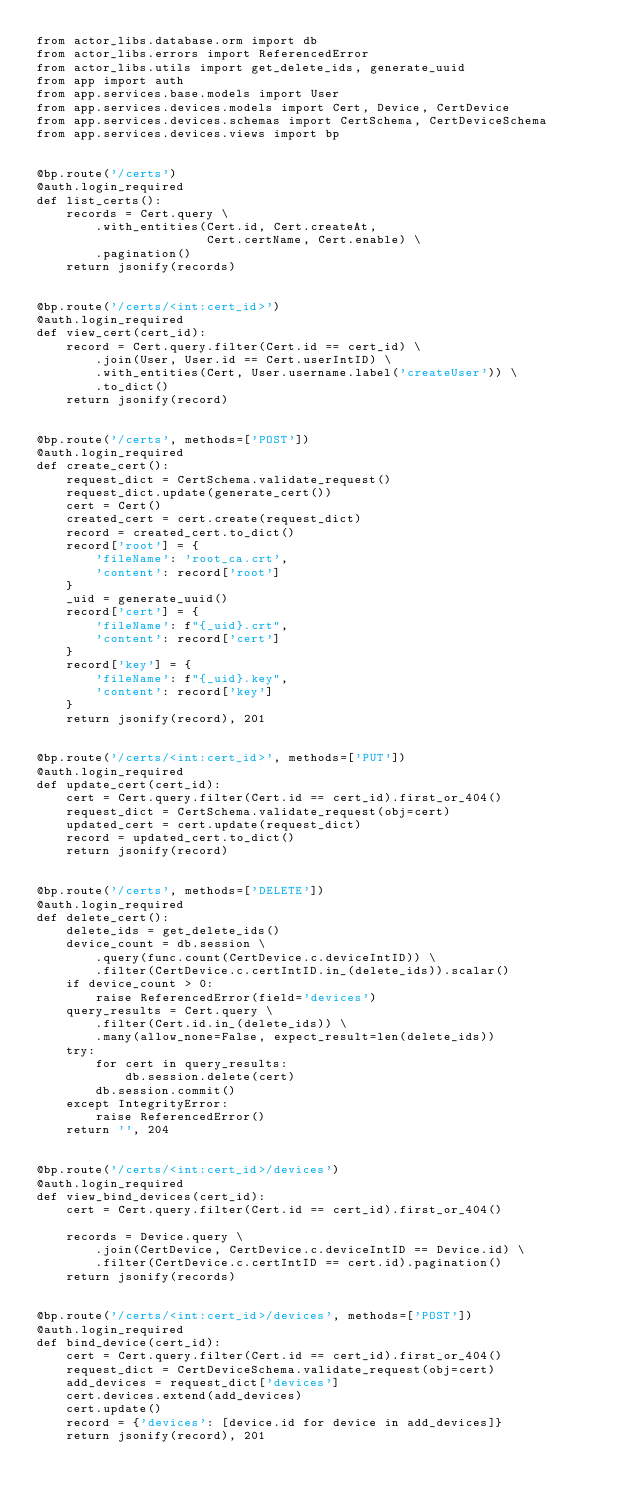Convert code to text. <code><loc_0><loc_0><loc_500><loc_500><_Python_>from actor_libs.database.orm import db
from actor_libs.errors import ReferencedError
from actor_libs.utils import get_delete_ids, generate_uuid
from app import auth
from app.services.base.models import User
from app.services.devices.models import Cert, Device, CertDevice
from app.services.devices.schemas import CertSchema, CertDeviceSchema
from app.services.devices.views import bp


@bp.route('/certs')
@auth.login_required
def list_certs():
    records = Cert.query \
        .with_entities(Cert.id, Cert.createAt,
                       Cert.certName, Cert.enable) \
        .pagination()
    return jsonify(records)


@bp.route('/certs/<int:cert_id>')
@auth.login_required
def view_cert(cert_id):
    record = Cert.query.filter(Cert.id == cert_id) \
        .join(User, User.id == Cert.userIntID) \
        .with_entities(Cert, User.username.label('createUser')) \
        .to_dict()
    return jsonify(record)


@bp.route('/certs', methods=['POST'])
@auth.login_required
def create_cert():
    request_dict = CertSchema.validate_request()
    request_dict.update(generate_cert())
    cert = Cert()
    created_cert = cert.create(request_dict)
    record = created_cert.to_dict()
    record['root'] = {
        'fileName': 'root_ca.crt',
        'content': record['root']
    }
    _uid = generate_uuid()
    record['cert'] = {
        'fileName': f"{_uid}.crt",
        'content': record['cert']
    }
    record['key'] = {
        'fileName': f"{_uid}.key",
        'content': record['key']
    }
    return jsonify(record), 201


@bp.route('/certs/<int:cert_id>', methods=['PUT'])
@auth.login_required
def update_cert(cert_id):
    cert = Cert.query.filter(Cert.id == cert_id).first_or_404()
    request_dict = CertSchema.validate_request(obj=cert)
    updated_cert = cert.update(request_dict)
    record = updated_cert.to_dict()
    return jsonify(record)


@bp.route('/certs', methods=['DELETE'])
@auth.login_required
def delete_cert():
    delete_ids = get_delete_ids()
    device_count = db.session \
        .query(func.count(CertDevice.c.deviceIntID)) \
        .filter(CertDevice.c.certIntID.in_(delete_ids)).scalar()
    if device_count > 0:
        raise ReferencedError(field='devices')
    query_results = Cert.query \
        .filter(Cert.id.in_(delete_ids)) \
        .many(allow_none=False, expect_result=len(delete_ids))
    try:
        for cert in query_results:
            db.session.delete(cert)
        db.session.commit()
    except IntegrityError:
        raise ReferencedError()
    return '', 204


@bp.route('/certs/<int:cert_id>/devices')
@auth.login_required
def view_bind_devices(cert_id):
    cert = Cert.query.filter(Cert.id == cert_id).first_or_404()

    records = Device.query \
        .join(CertDevice, CertDevice.c.deviceIntID == Device.id) \
        .filter(CertDevice.c.certIntID == cert.id).pagination()
    return jsonify(records)


@bp.route('/certs/<int:cert_id>/devices', methods=['POST'])
@auth.login_required
def bind_device(cert_id):
    cert = Cert.query.filter(Cert.id == cert_id).first_or_404()
    request_dict = CertDeviceSchema.validate_request(obj=cert)
    add_devices = request_dict['devices']
    cert.devices.extend(add_devices)
    cert.update()
    record = {'devices': [device.id for device in add_devices]}
    return jsonify(record), 201

</code> 